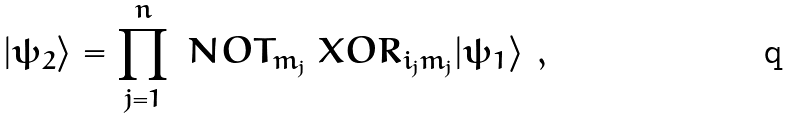<formula> <loc_0><loc_0><loc_500><loc_500>| \psi _ { 2 } \rangle = \prod _ { j = 1 } ^ { n } \ N O T _ { m _ { j } } \ X O R _ { i _ { j } m _ { j } } | \psi _ { 1 } \rangle \ ,</formula> 